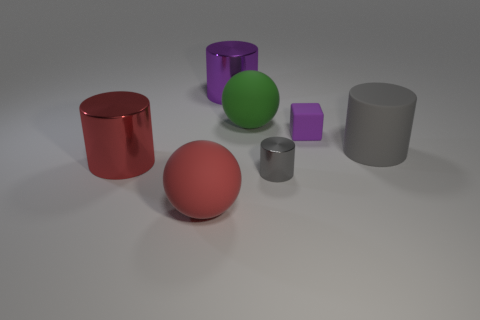Subtract all yellow cylinders. Subtract all gray spheres. How many cylinders are left? 4 Add 1 purple shiny balls. How many objects exist? 8 Subtract all cylinders. How many objects are left? 3 Add 5 small rubber cubes. How many small rubber cubes exist? 6 Subtract 1 red balls. How many objects are left? 6 Subtract all large gray balls. Subtract all big gray rubber objects. How many objects are left? 6 Add 6 big red metallic things. How many big red metallic things are left? 7 